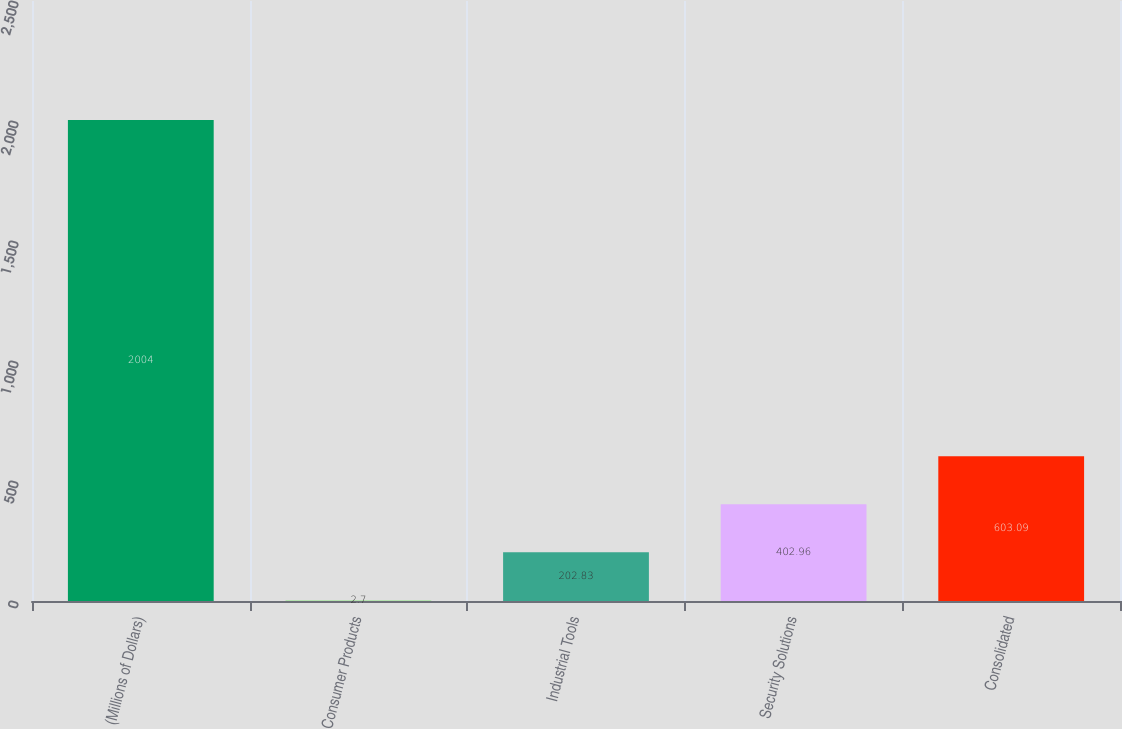<chart> <loc_0><loc_0><loc_500><loc_500><bar_chart><fcel>(Millions of Dollars)<fcel>Consumer Products<fcel>Industrial Tools<fcel>Security Solutions<fcel>Consolidated<nl><fcel>2004<fcel>2.7<fcel>202.83<fcel>402.96<fcel>603.09<nl></chart> 